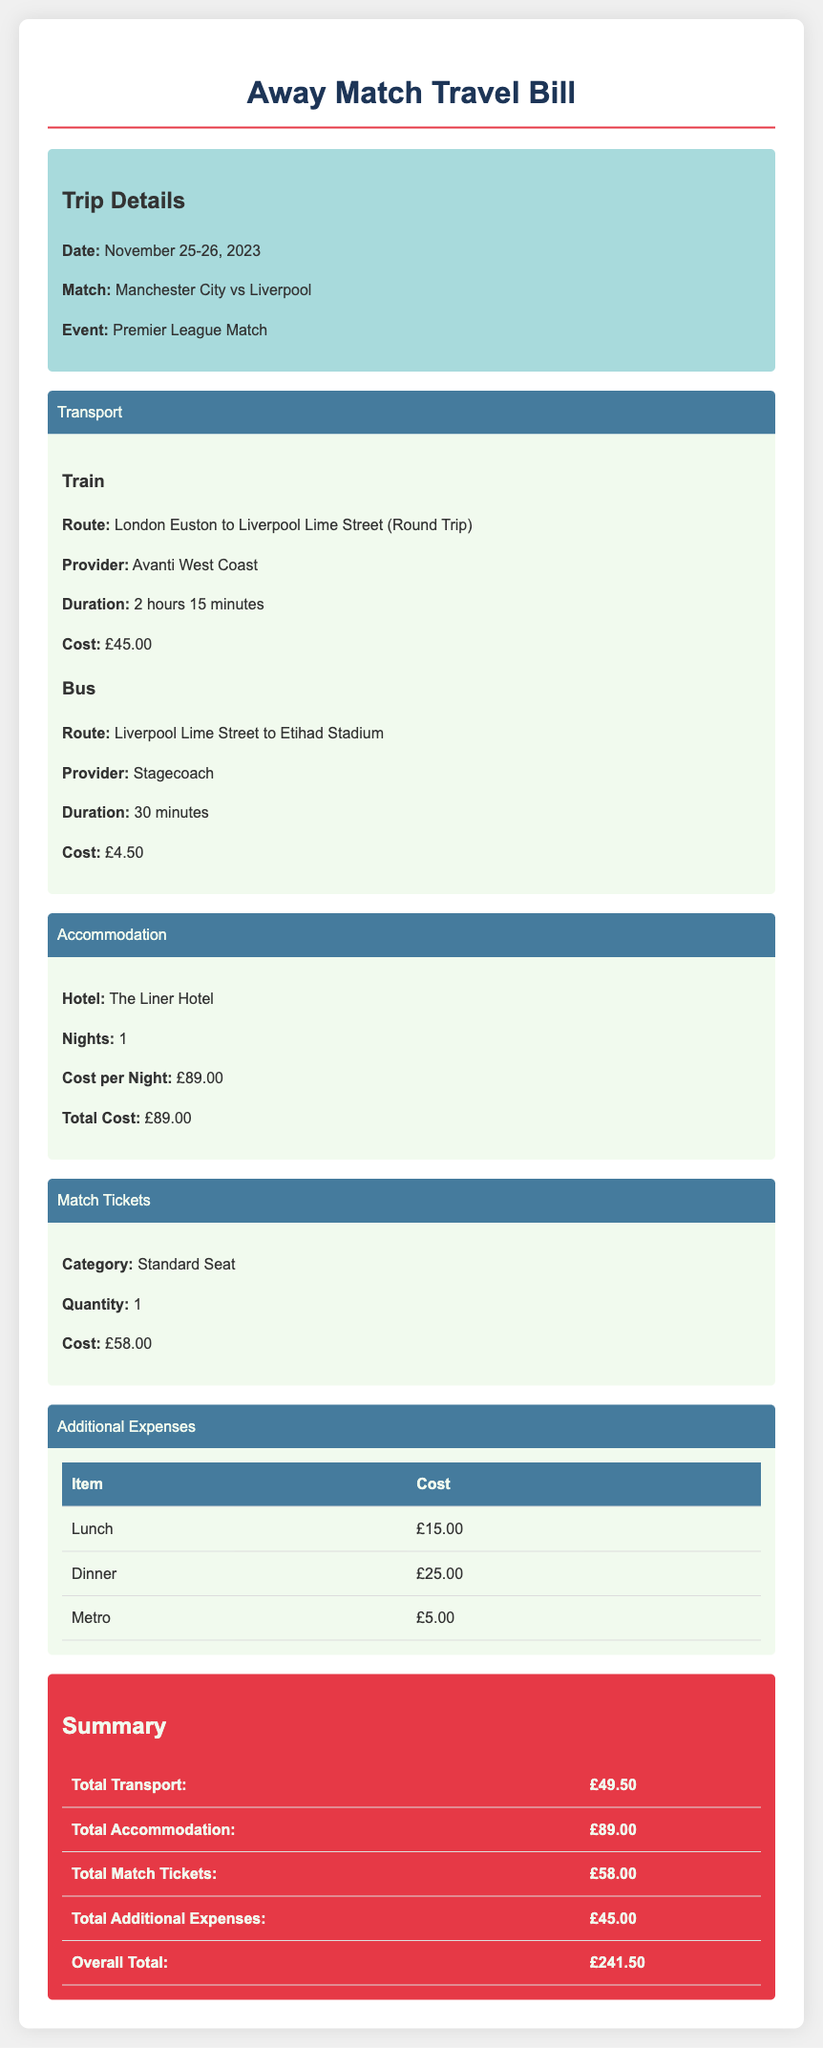What was the date of the trip? The date of the trip is mentioned as November 25-26, 2023.
Answer: November 25-26, 2023 What was the cost of the train fare? The document states that the cost of the train fare is £45.00.
Answer: £45.00 What is the name of the hotel? The hotel listed in the expenses is The Liner Hotel.
Answer: The Liner Hotel How much was paid for match tickets? The cost of the match ticket is specified as £58.00.
Answer: £58.00 What was the total cost for accommodation? The total cost for accommodation is shown as £89.00.
Answer: £89.00 What is the overall total expense? The overall total expense combines all the costs and is noted as £241.50.
Answer: £241.50 What type of event is this trip for? The trip is for a Premier League Match.
Answer: Premier League Match How many nights did the accommodation cover? The document indicates that the accommodation covered 1 night.
Answer: 1 What was the cost of additional expenses? The total cost for additional expenses is listed as £45.00.
Answer: £45.00 Which transport provider operated the train route? The train provider mentioned is Avanti West Coast.
Answer: Avanti West Coast 